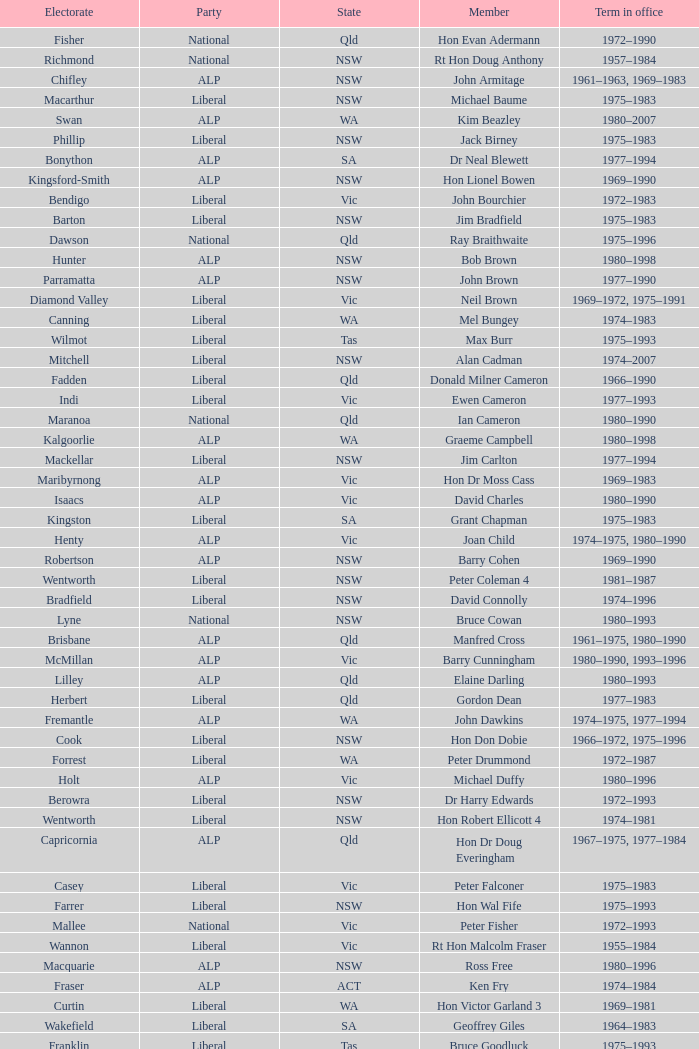Which party had a member from the state of Vic and an Electorate called Wannon? Liberal. 